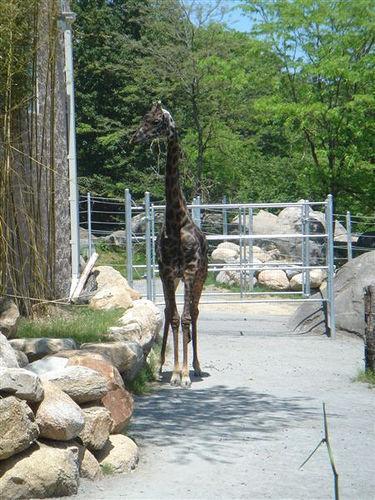How many giraffes are there?
Give a very brief answer. 1. How many people are in the picture?
Give a very brief answer. 0. 